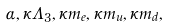Convert formula to latex. <formula><loc_0><loc_0><loc_500><loc_500>\alpha , \kappa \Lambda _ { 3 } , \kappa m _ { e } , \kappa m _ { u } , \kappa m _ { d } ,</formula> 